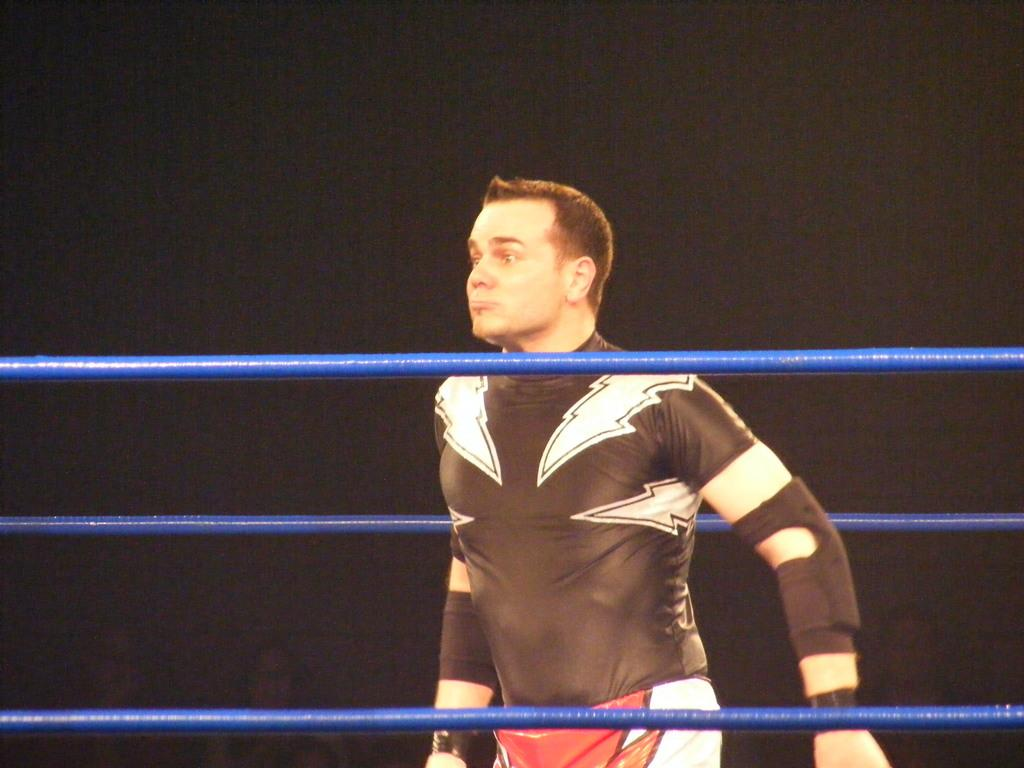What is the main subject of the image? There is a person in the image. What can be observed about the person's attire? The person is wearing a dress with black, white, and red colors. Where is the person located in the image? The person is standing in a wrestling ring. What color are the ropes in the wrestling ring? The ropes in the wrestling ring are blue-colored. What is the color of the background in the image? The background of the image is black. What type of faucet can be seen in the image? There is no faucet present in the image. How does the person's attire reflect the values of society in the image? The image does not provide any information about the values of society, and the person's attire is not discussed in terms of societal values. 